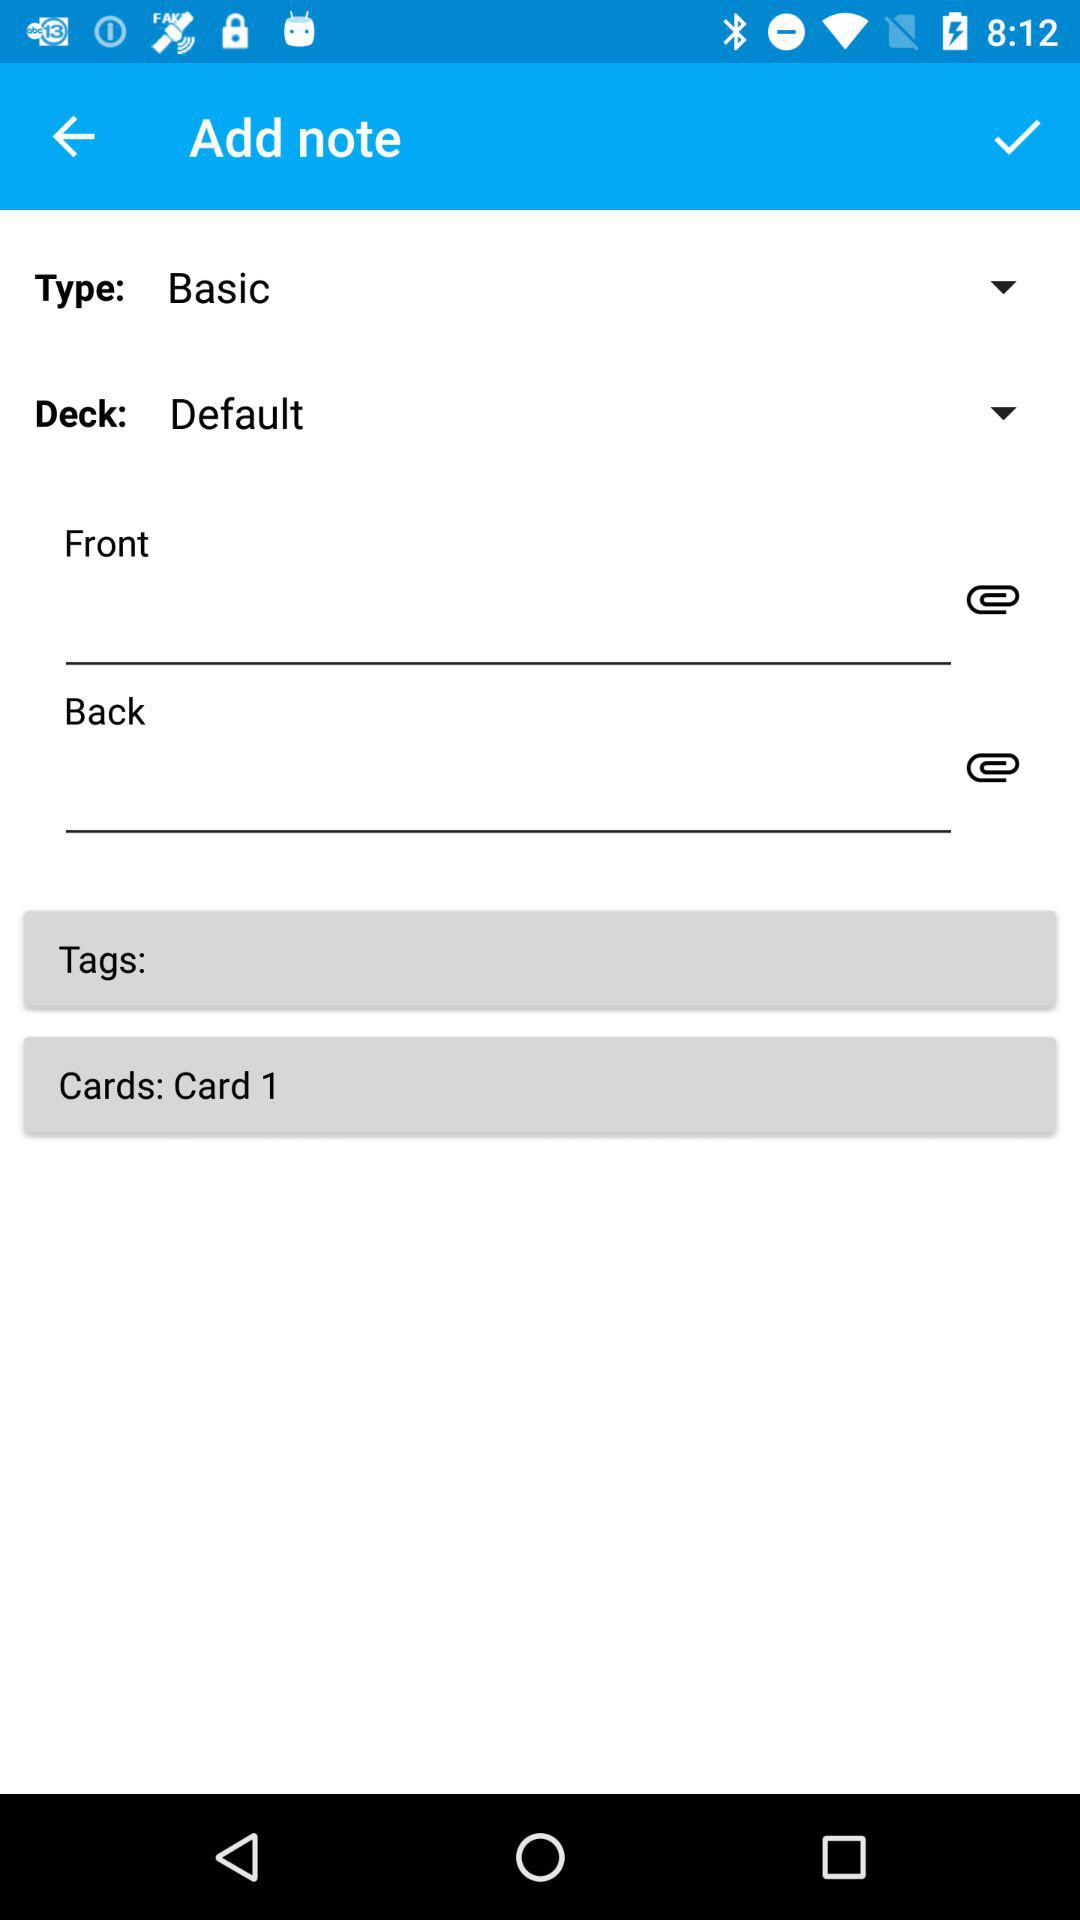What are the selected cards? The selected card is "Card 1". 